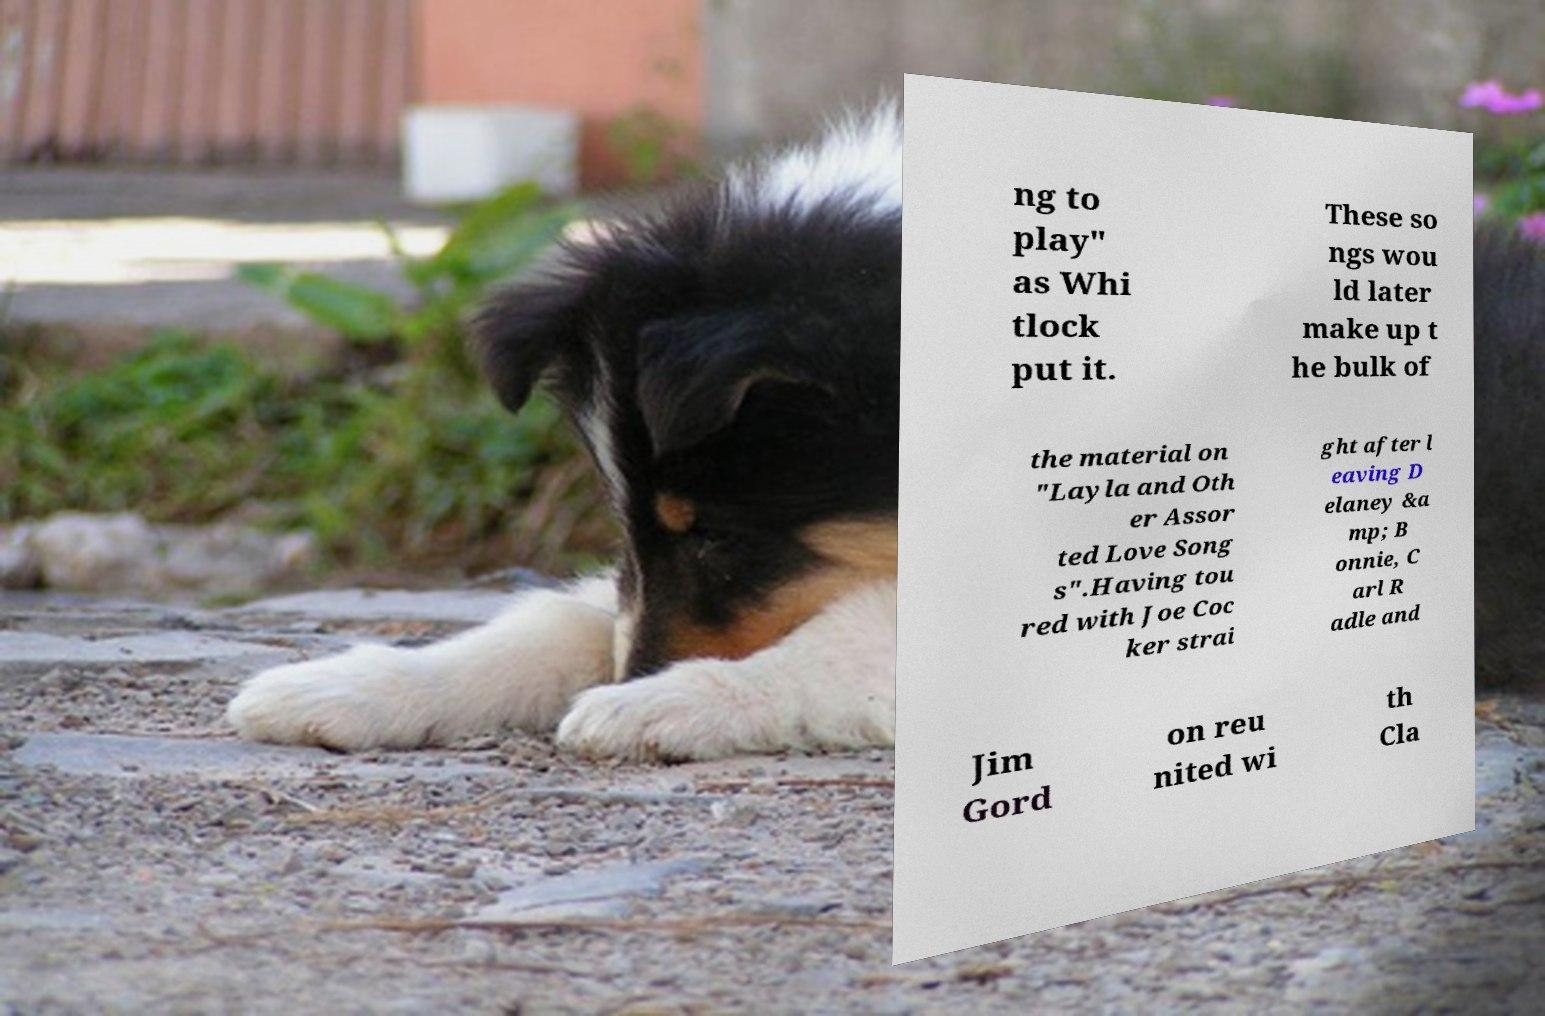Could you assist in decoding the text presented in this image and type it out clearly? ng to play" as Whi tlock put it. These so ngs wou ld later make up t he bulk of the material on "Layla and Oth er Assor ted Love Song s".Having tou red with Joe Coc ker strai ght after l eaving D elaney &a mp; B onnie, C arl R adle and Jim Gord on reu nited wi th Cla 